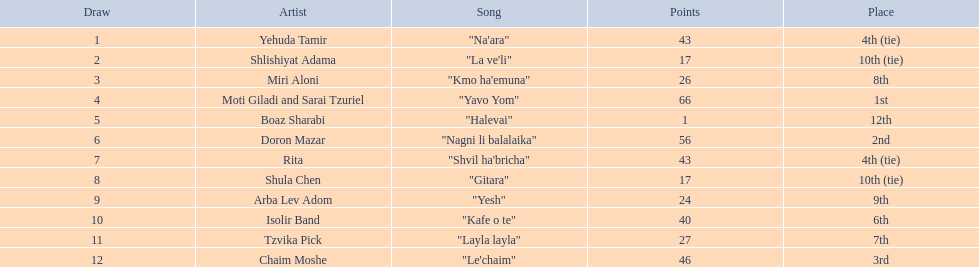What are the scores in the contest? 43, 17, 26, 66, 1, 56, 43, 17, 24, 40, 27, 46. What is the minimum score? 1. Which artist obtained this score? Boaz Sharabi. 